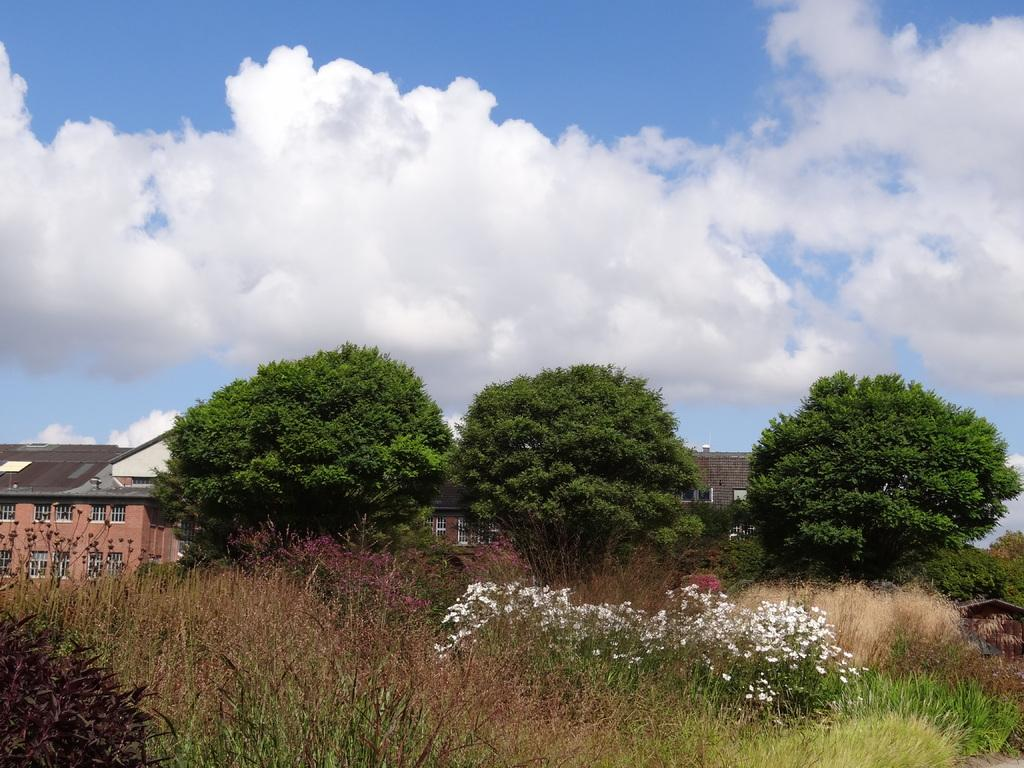What types of vegetation can be seen in the image? There are plants and trees in the image. What color are the flowers in the image? There are white color flowers in the image. What type of structures are present in the image? There are homes in the image. What is the color of the sky in the image? The sky is blue in the image. What else can be seen in the sky in the image? There are clouds visible in the image. How does the team of squirrels work together to maintain balance on the stream in the image? There are no squirrels or streams present in the image, so this scenario cannot be observed. 